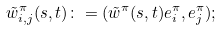Convert formula to latex. <formula><loc_0><loc_0><loc_500><loc_500>\tilde { w } ^ { \pi } _ { i , j } ( s , t ) \colon = ( \tilde { w } ^ { \pi } ( s , t ) e _ { i } ^ { \pi } , e _ { j } ^ { \pi } ) ;</formula> 